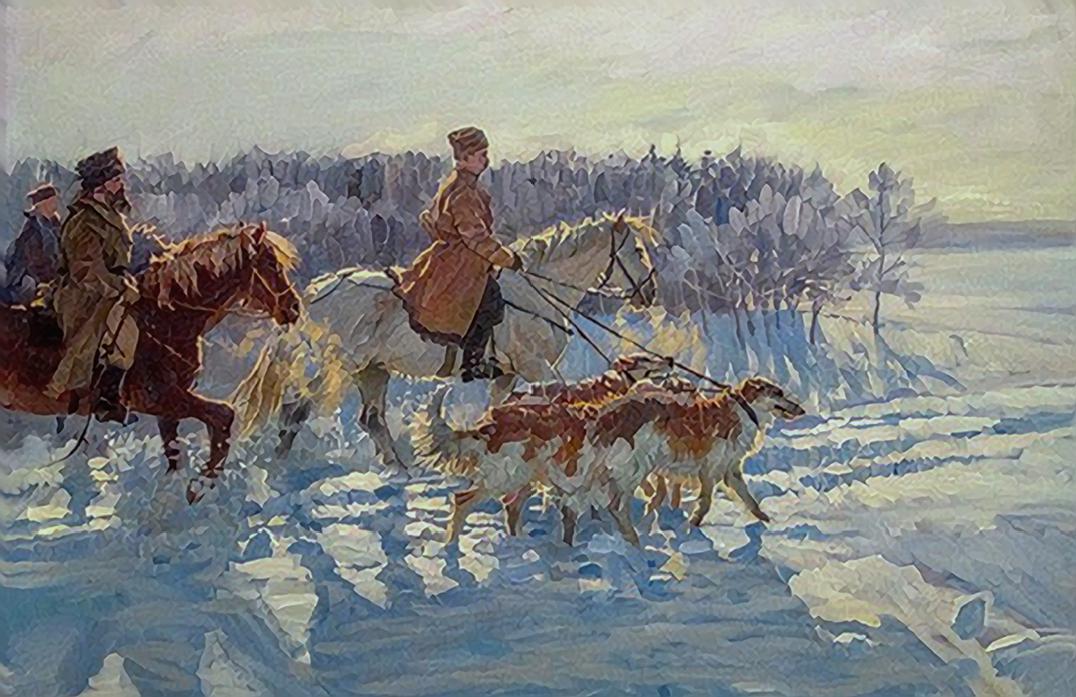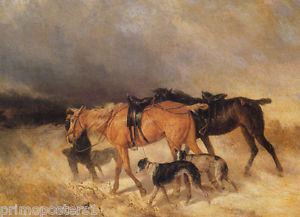The first image is the image on the left, the second image is the image on the right. For the images shown, is this caption "One image shows at least one man on a horse with at least two dogs standing next to the horse, and the other image shows horses but no wagon." true? Answer yes or no. Yes. 